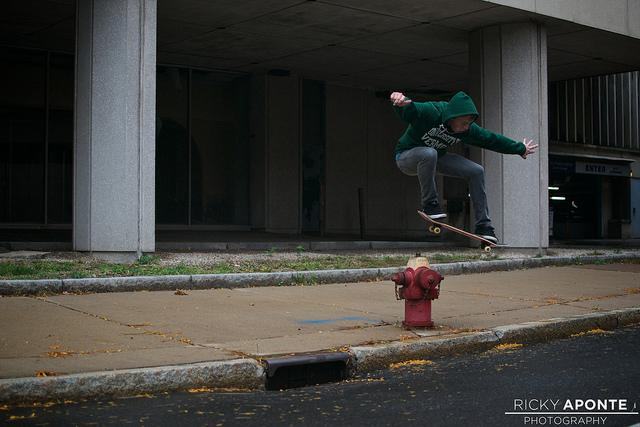Who probably took the picture? Please explain your reasoning. ricky aponte. The name of the photographer is in the lower right corner. 